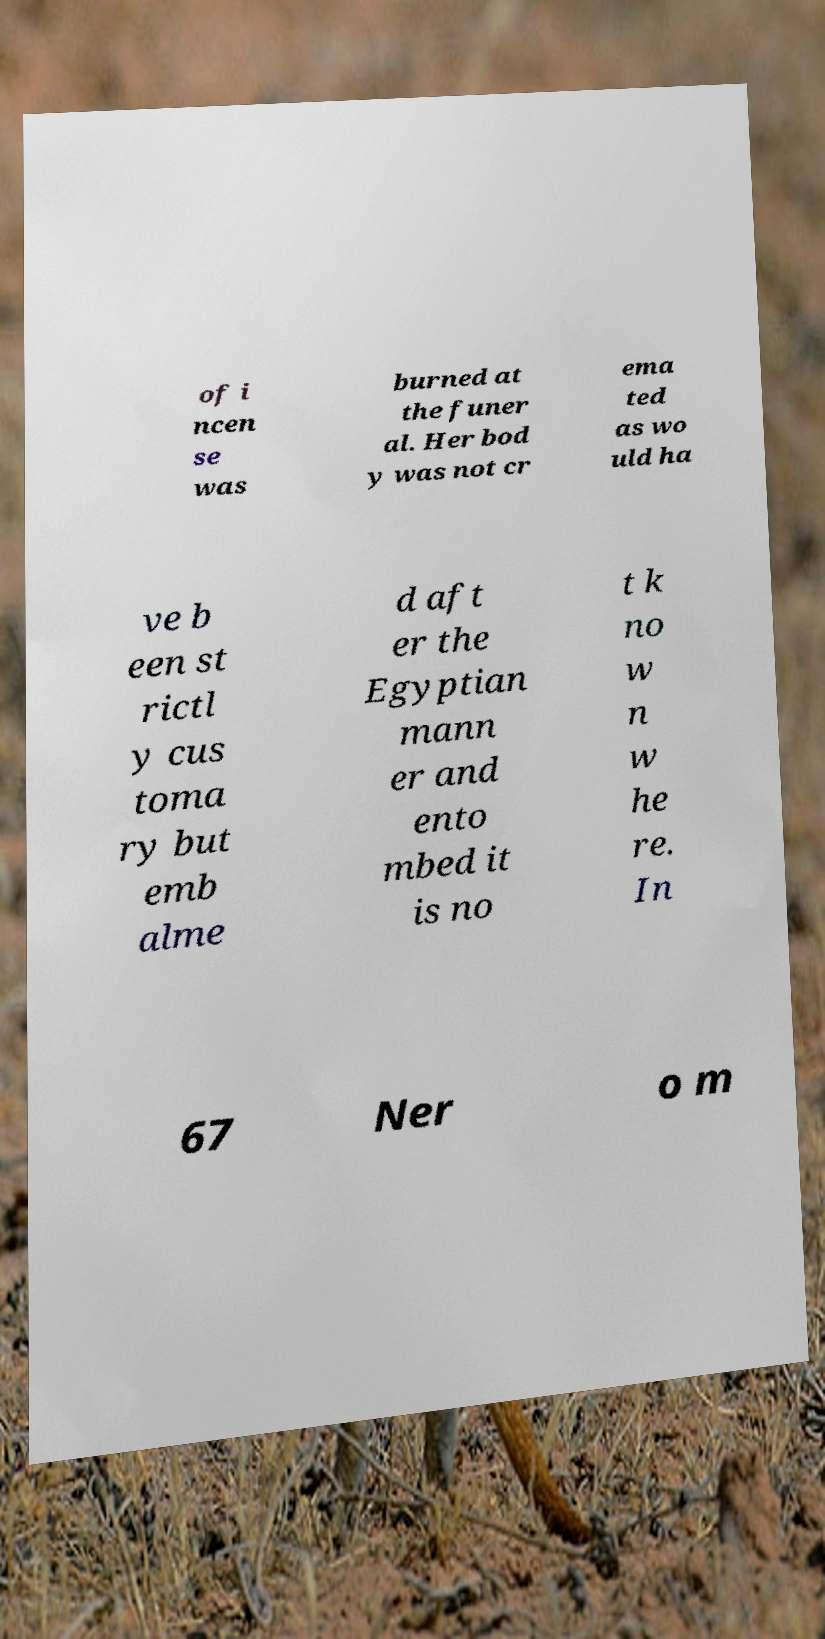I need the written content from this picture converted into text. Can you do that? of i ncen se was burned at the funer al. Her bod y was not cr ema ted as wo uld ha ve b een st rictl y cus toma ry but emb alme d aft er the Egyptian mann er and ento mbed it is no t k no w n w he re. In 67 Ner o m 